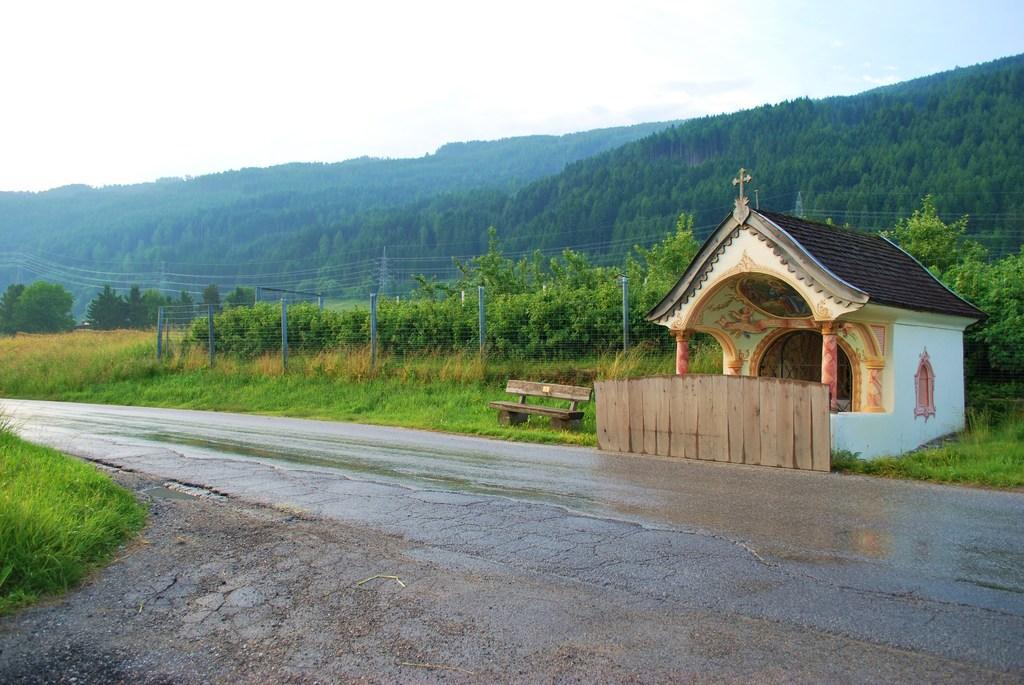Describe this image in one or two sentences. At the bottom of the image there is a road. Behind the road there is a small fencing wall. Behind the wall there is a house with roofs, walls, pillars and also there is a window. Beside that house there is a bench on the ground. On the ground there is grass. And also there is fencing. Behind the fencing there are ties. In the background there are towers with wires. In the background there are many trees and also there are hills. At the top of the image there is sky. 